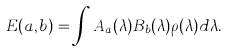Convert formula to latex. <formula><loc_0><loc_0><loc_500><loc_500>E ( a , b ) = \int A _ { a } ( \lambda ) B _ { b } ( \lambda ) \rho ( \lambda ) d \lambda .</formula> 